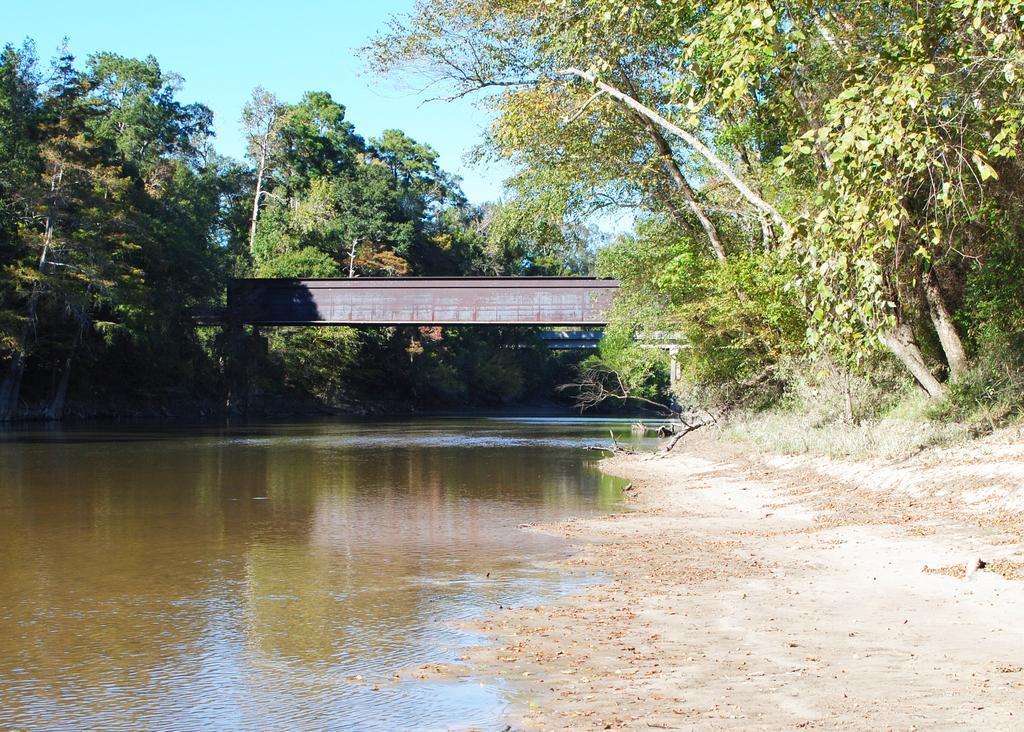How would you summarize this image in a sentence or two? In the image we can see a bridge, trees, river, sand and the sky. 